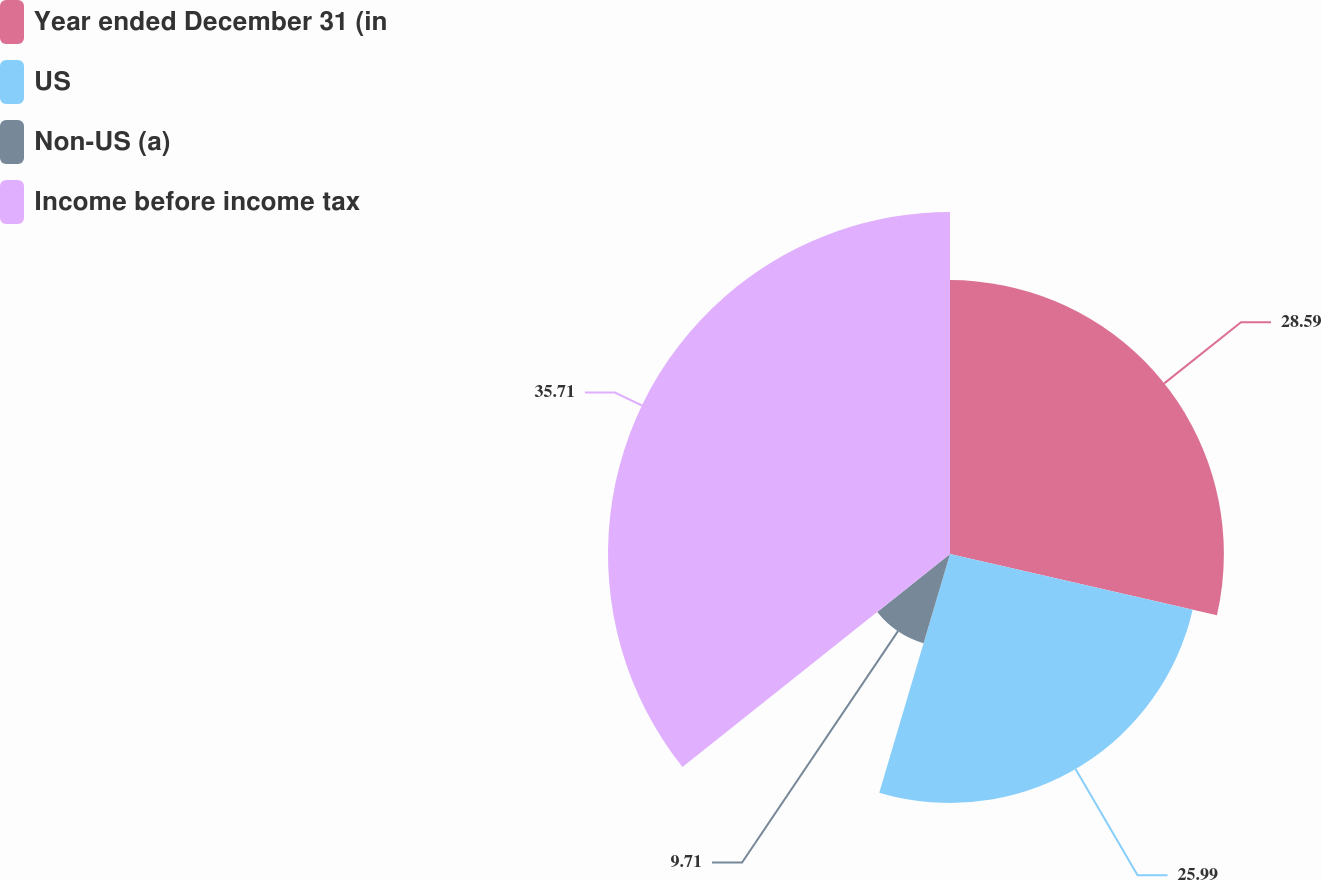<chart> <loc_0><loc_0><loc_500><loc_500><pie_chart><fcel>Year ended December 31 (in<fcel>US<fcel>Non-US (a)<fcel>Income before income tax<nl><fcel>28.59%<fcel>25.99%<fcel>9.71%<fcel>35.7%<nl></chart> 